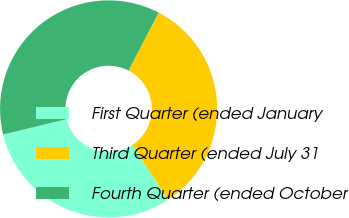Convert chart to OTSL. <chart><loc_0><loc_0><loc_500><loc_500><pie_chart><fcel>First Quarter (ended January<fcel>Third Quarter (ended July 31<fcel>Fourth Quarter (ended October<nl><fcel>30.44%<fcel>33.14%<fcel>36.42%<nl></chart> 